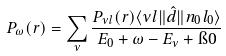Convert formula to latex. <formula><loc_0><loc_0><loc_500><loc_500>P _ { \omega } ( r ) = \sum _ { \nu } \frac { P _ { \nu l } ( r ) \langle \nu l \| \hat { d } \| n _ { 0 } l _ { 0 } \rangle } { E _ { 0 } + \omega - E _ { \nu } + \i 0 }</formula> 